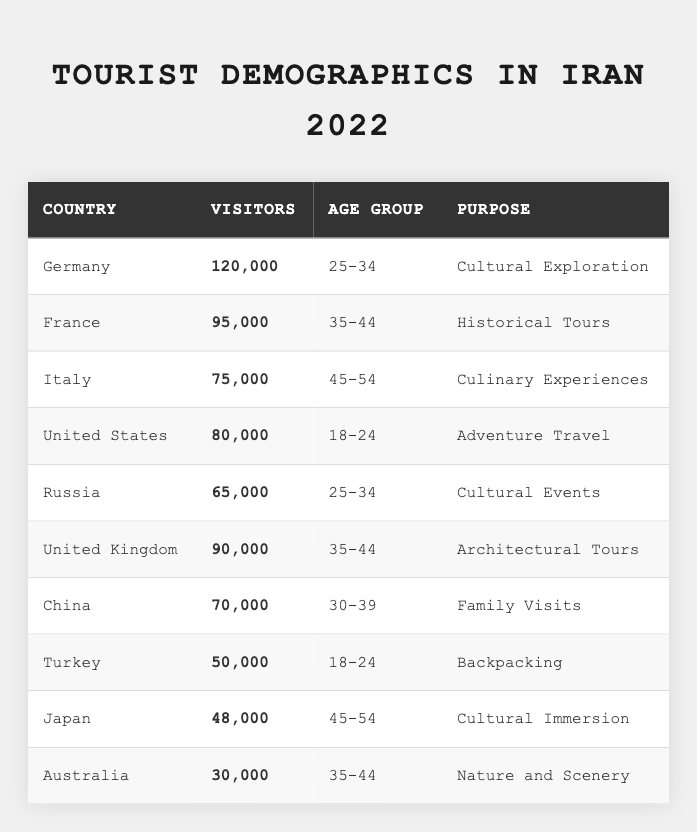What is the total number of visitors from Germany? The table shows that the number of visitors from Germany is 120,000.
Answer: 120,000 Which country had the highest number of visitors in 2022? The highest number of visitors is found in the data for Germany, with 120,000 visitors.
Answer: Germany What age group had visitors from France? According to the table, visitors from France fell into the age group of 35-44.
Answer: 35-44 How many visitors came from the United States? The table indicates that there were 80,000 visitors from the United States.
Answer: 80,000 Which purpose of travel attracted the most visitors from the United Kingdom? The table states that the purpose of travel from the United Kingdom was Architectural Tours, with 90,000 visitors.
Answer: Architectural Tours What is the average number of visitors for age group 18-24? The total number of visitors for age group 18-24 is the sum of visitors from the United States (80,000) and Turkey (50,000), totaling 130,000. Dividing by 2 gives an average of 65,000.
Answer: 65,000 Is there a country with visitors focused on Culinary Experiences? Yes, Italy had visitors with the purpose of Culinary Experiences.
Answer: Yes How many visitors were there from countries that had the purpose of Cultural Exploration and Cultural Events combined? The visitors for Cultural Exploration from Germany are 120,000, and for Cultural Events from Russia, the total is 65,000. Adding these gives 185,000 visitors in total.
Answer: 185,000 In which age group do visitors from Japan fall? The table shows that visitors from Japan belong to the age group of 45-54.
Answer: 45-54 Which country had the least number of visitors, and how many were there? Australia had the least number of visitors at 30,000 according to the table.
Answer: Australia, 30,000 What is the total number of visitors from the countries whose travelers are interested in nature or scenery experiences? Australia's 30,000 visitors were for Nature and Scenery. There are no other specific nature-related visits listed, so the total remains 30,000.
Answer: 30,000 How many more visitors were there from Germany compared to Italy? Germany had 120,000 visitors while Italy had 75,000. The difference is 120,000 - 75,000 = 45,000.
Answer: 45,000 